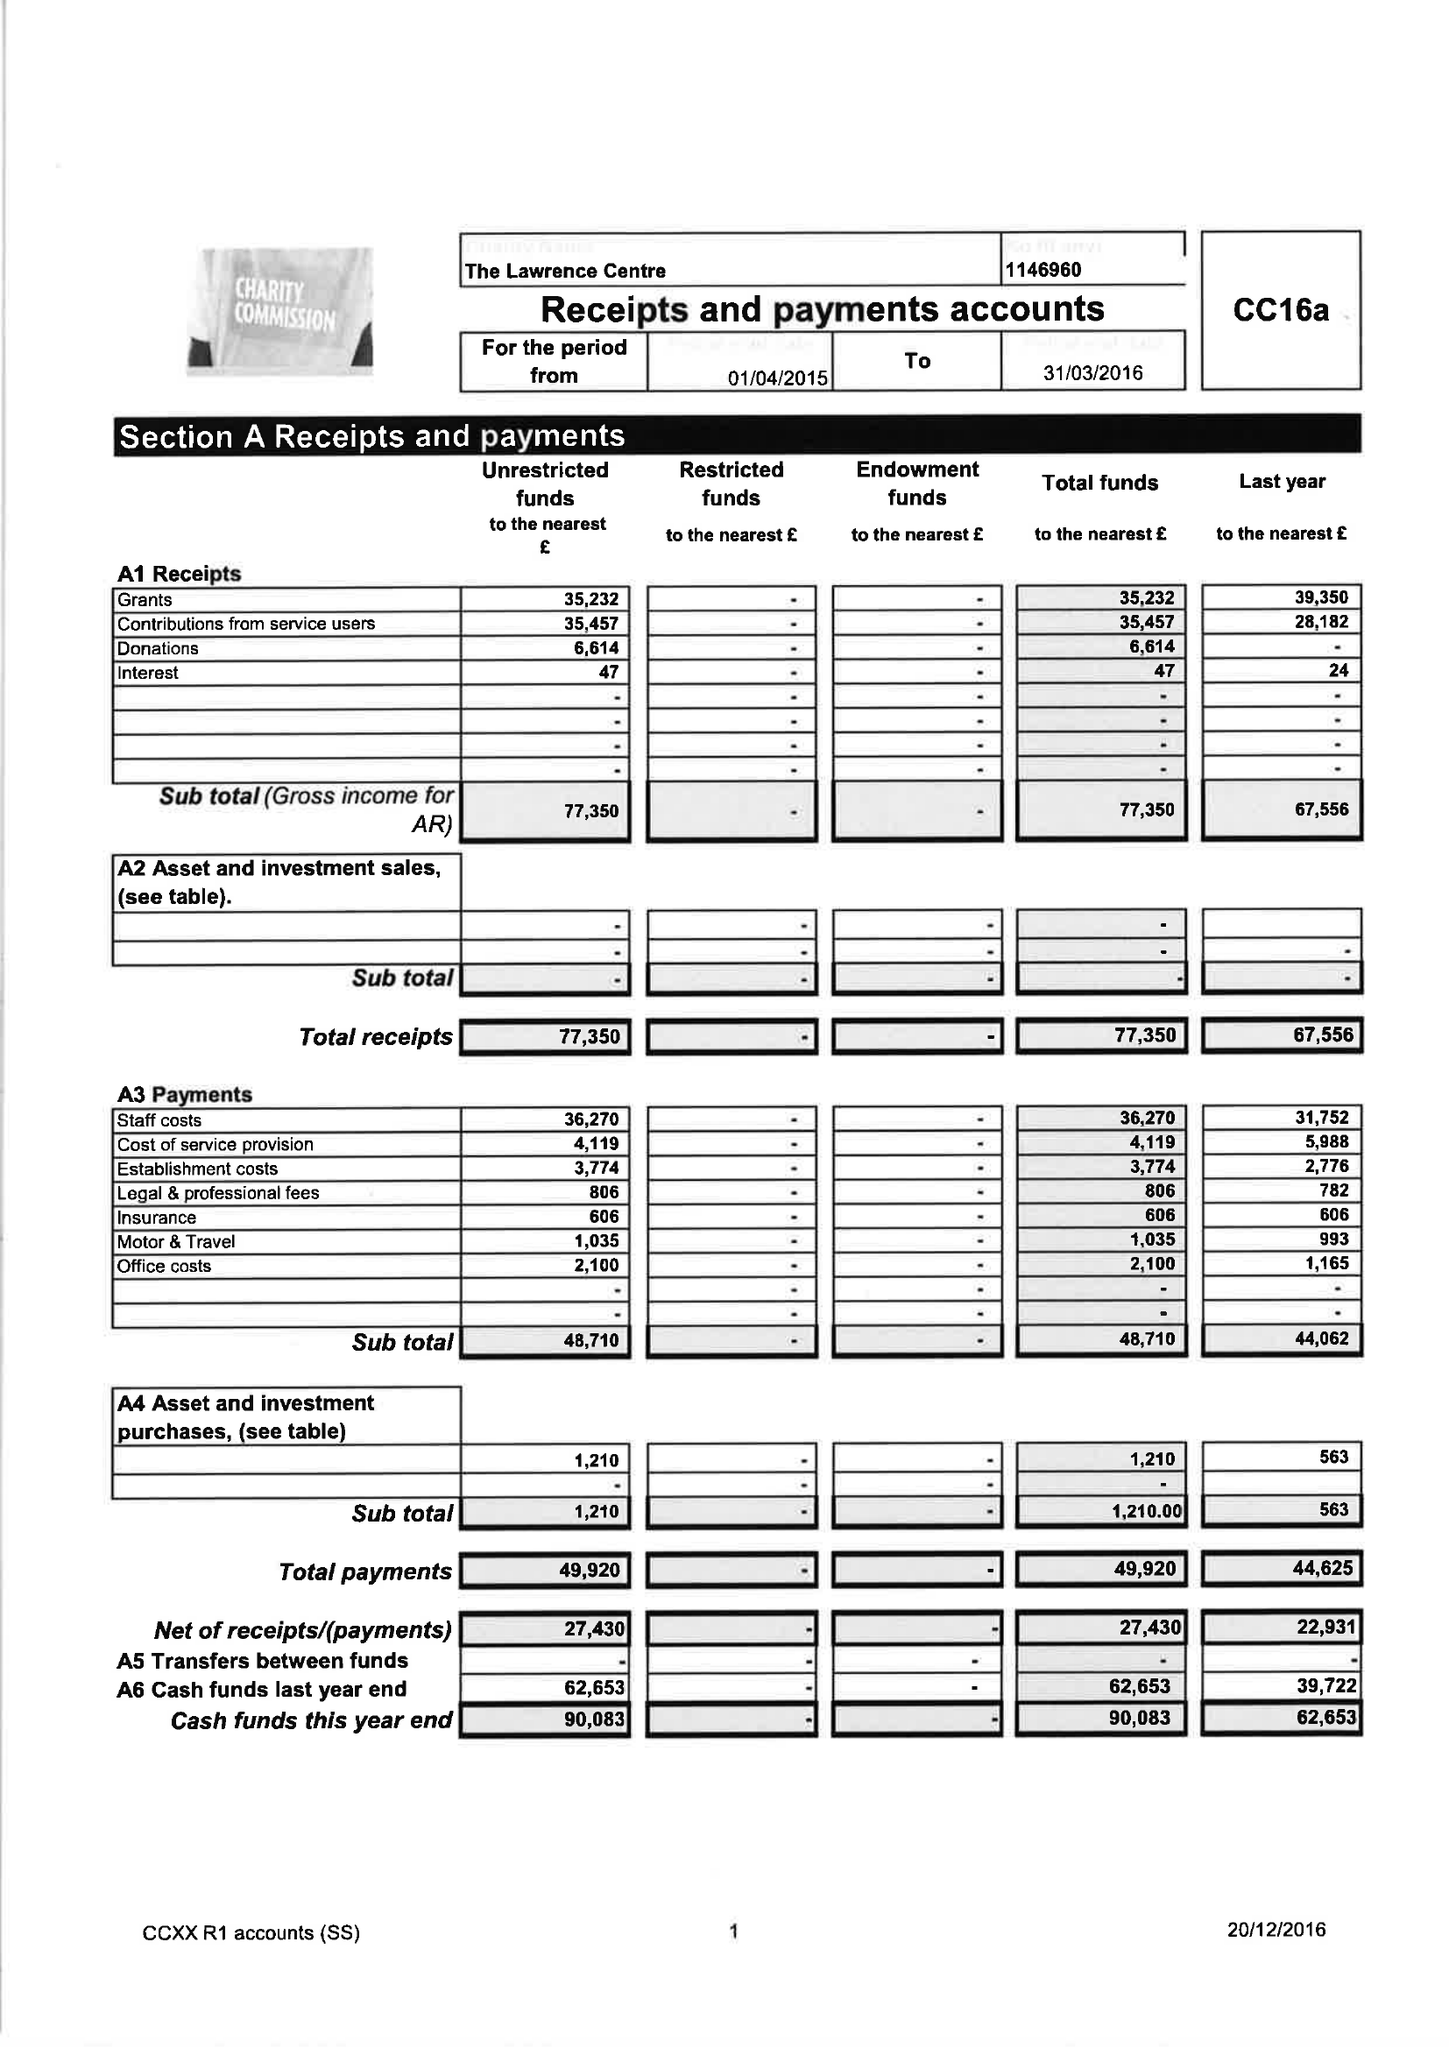What is the value for the address__post_town?
Answer the question using a single word or phrase. WELLS 